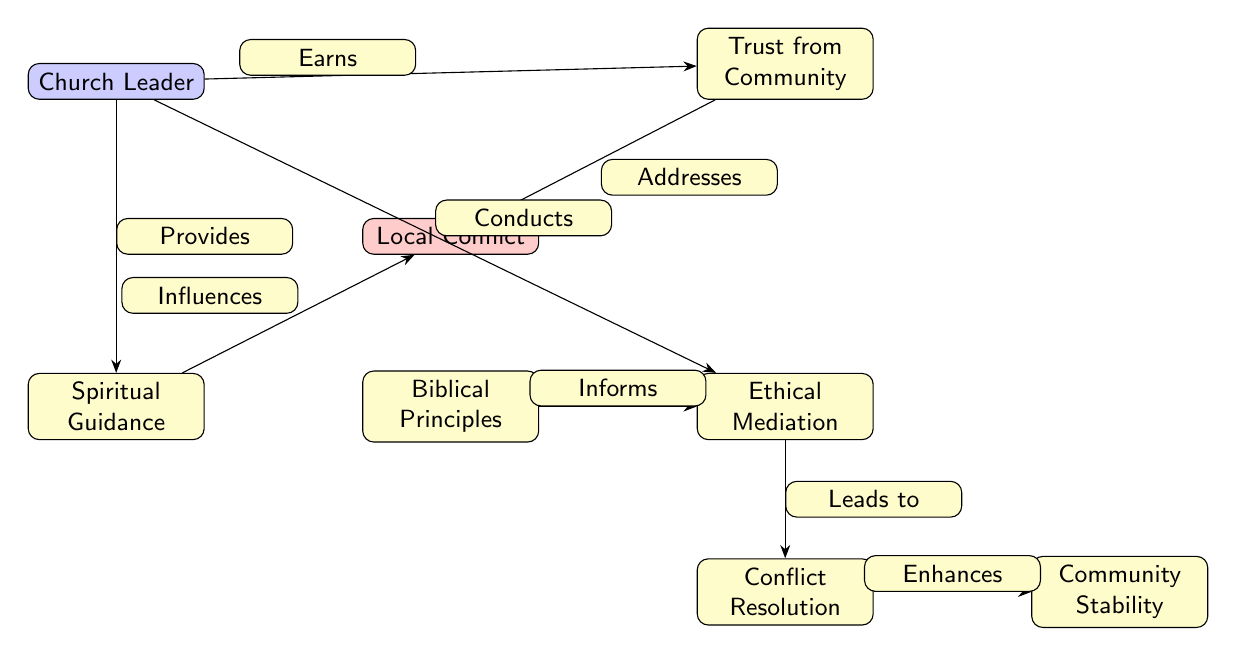What is the central node in the diagram? The central node is the Church Leader, as it is the starting point from which other nodes branch out and it plays a pivotal role in the mediation process.
Answer: Church Leader How many nodes are there in total? There are 7 nodes in total, which include Church Leader, Local Conflict, Trust from Community, Spiritual Guidance, Ethical Mediation, Conflict Resolution, and Community Stability.
Answer: 7 What connection does the Church Leader have with the Trust from Community? The Church Leader earns the trust from the community, indicating a direct relationship where the Church Leader actively contributes to gaining community trust.
Answer: Earns Which node is influenced by Spiritual Guidance? The Local Conflict node is influenced by Spiritual Guidance, meaning that the guidance provided has a direct impact on this aspect of the conflicts.
Answer: Local Conflict What leads to Conflict Resolution? Ethical Mediation leads to Conflict Resolution, indicating that mediation is a precursor to resolving conflicts in the community.
Answer: Leads to How does the Trust from Community address Local Conflict? The Trust from Community addresses Local Conflict directly, emphasizing the importance of community trust in managing and resolving local disputes.
Answer: Addresses What principle informs Ethical Mediation? Biblical Principles inform Ethical Mediation, suggesting that the mediation strategies employed are grounded in biblical teachings.
Answer: Informs What enhances Community Stability? Conflict Resolution enhances Community Stability, meaning that resolving conflicts contributes positively to the overall stability within the community.
Answer: Enhances 